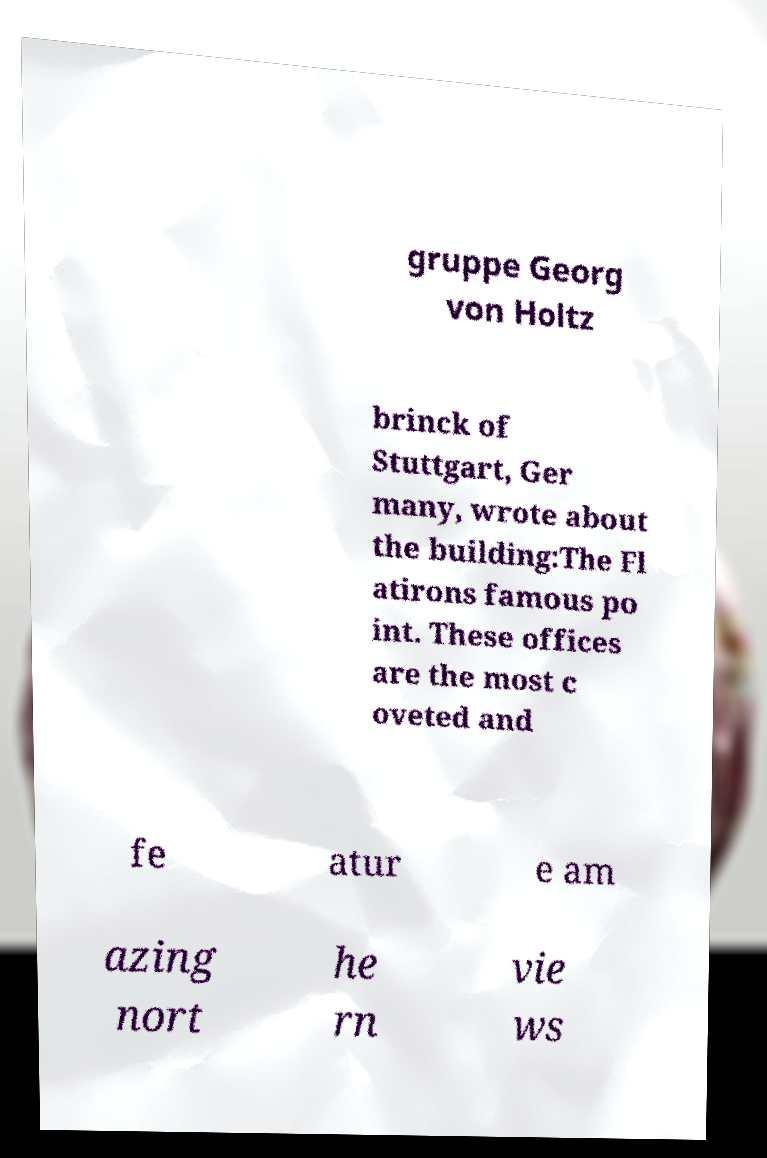There's text embedded in this image that I need extracted. Can you transcribe it verbatim? gruppe Georg von Holtz brinck of Stuttgart, Ger many, wrote about the building:The Fl atirons famous po int. These offices are the most c oveted and fe atur e am azing nort he rn vie ws 